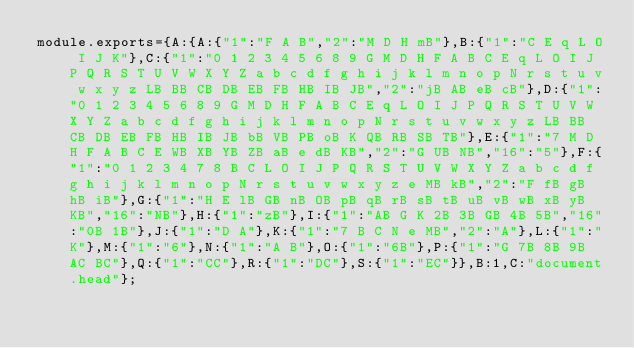Convert code to text. <code><loc_0><loc_0><loc_500><loc_500><_JavaScript_>module.exports={A:{A:{"1":"F A B","2":"M D H mB"},B:{"1":"C E q L O I J K"},C:{"1":"0 1 2 3 4 5 6 8 9 G M D H F A B C E q L O I J P Q R S T U V W X Y Z a b c d f g h i j k l m n o p N r s t u v w x y z LB BB CB DB EB FB HB IB JB","2":"jB AB eB cB"},D:{"1":"0 1 2 3 4 5 6 8 9 G M D H F A B C E q L O I J P Q R S T U V W X Y Z a b c d f g h i j k l m n o p N r s t u v w x y z LB BB CB DB EB FB HB IB JB bB VB PB oB K QB RB SB TB"},E:{"1":"7 M D H F A B C E WB XB YB ZB aB e dB KB","2":"G UB NB","16":"5"},F:{"1":"0 1 2 3 4 7 8 B C L O I J P Q R S T U V W X Y Z a b c d f g h i j k l m n o p N r s t u v w x y z e MB kB","2":"F fB gB hB iB"},G:{"1":"H E lB GB nB OB pB qB rB sB tB uB vB wB xB yB KB","16":"NB"},H:{"1":"zB"},I:{"1":"AB G K 2B 3B GB 4B 5B","16":"0B 1B"},J:{"1":"D A"},K:{"1":"7 B C N e MB","2":"A"},L:{"1":"K"},M:{"1":"6"},N:{"1":"A B"},O:{"1":"6B"},P:{"1":"G 7B 8B 9B AC BC"},Q:{"1":"CC"},R:{"1":"DC"},S:{"1":"EC"}},B:1,C:"document.head"};
</code> 